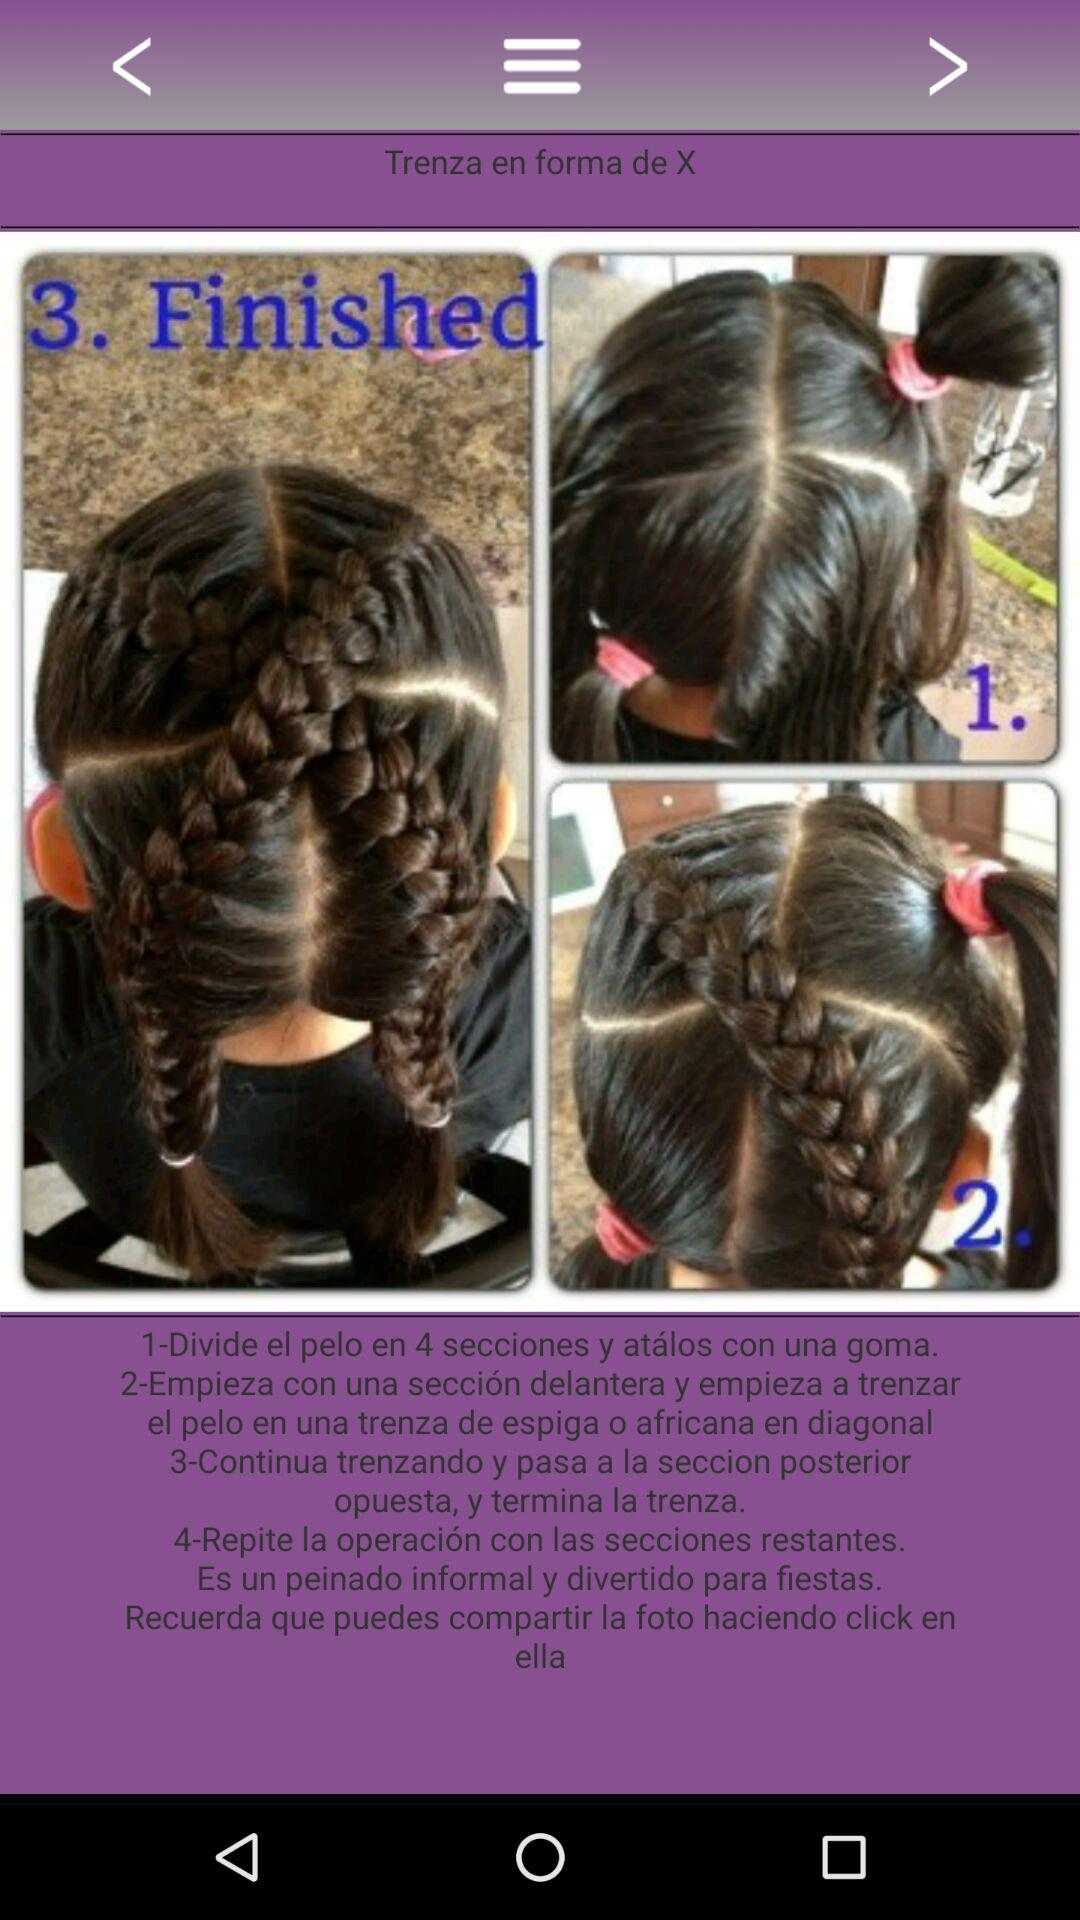How many steps are there in the tutorial?
Answer the question using a single word or phrase. 4 